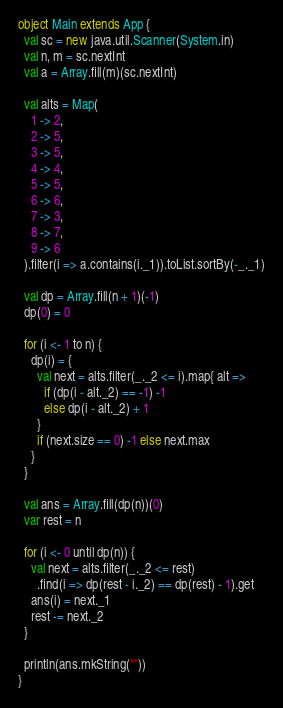<code> <loc_0><loc_0><loc_500><loc_500><_Scala_>object Main extends App {
  val sc = new java.util.Scanner(System.in)
  val n, m = sc.nextInt
  val a = Array.fill(m)(sc.nextInt)

  val alts = Map(
    1 -> 2,
    2 -> 5,
    3 -> 5,
    4 -> 4,
    5 -> 5,
    6 -> 6,
    7 -> 3,
    8 -> 7,
    9 -> 6
  ).filter(i => a.contains(i._1)).toList.sortBy(-_._1)

  val dp = Array.fill(n + 1)(-1)
  dp(0) = 0

  for (i <- 1 to n) {
    dp(i) = {
      val next = alts.filter(_._2 <= i).map{ alt =>
        if (dp(i - alt._2) == -1) -1
        else dp(i - alt._2) + 1
      }
      if (next.size == 0) -1 else next.max
    }
  }

  val ans = Array.fill(dp(n))(0)
  var rest = n

  for (i <- 0 until dp(n)) {
    val next = alts.filter(_._2 <= rest)
      .find(i => dp(rest - i._2) == dp(rest) - 1).get
    ans(i) = next._1
    rest -= next._2
  }

  println(ans.mkString(""))
}</code> 